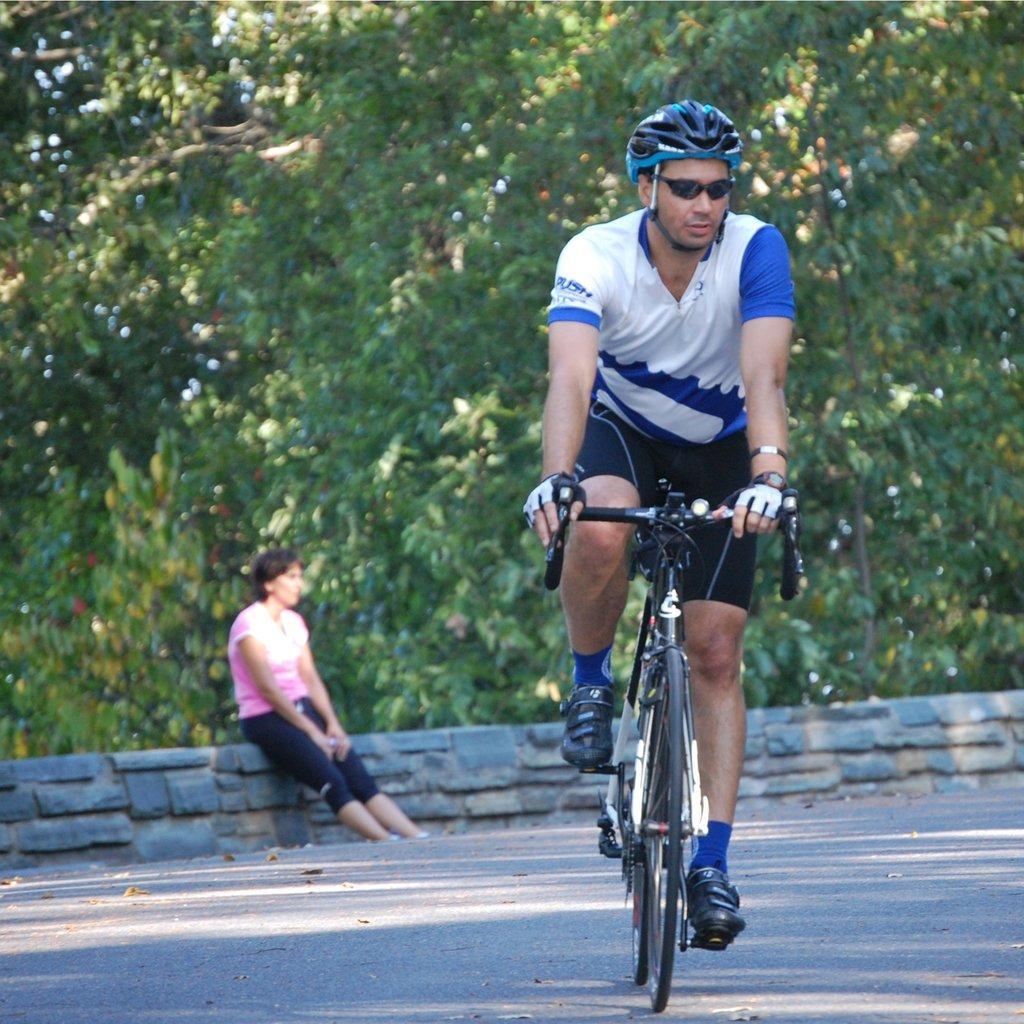Could you give a brief overview of what you see in this image? In this image there are trees towards the top of the image, there is road towards the bottom of the image, there is a woman sitting on the wall, there is a man riding a bicycle, he is wearing a helmet, he is wearing goggles. 